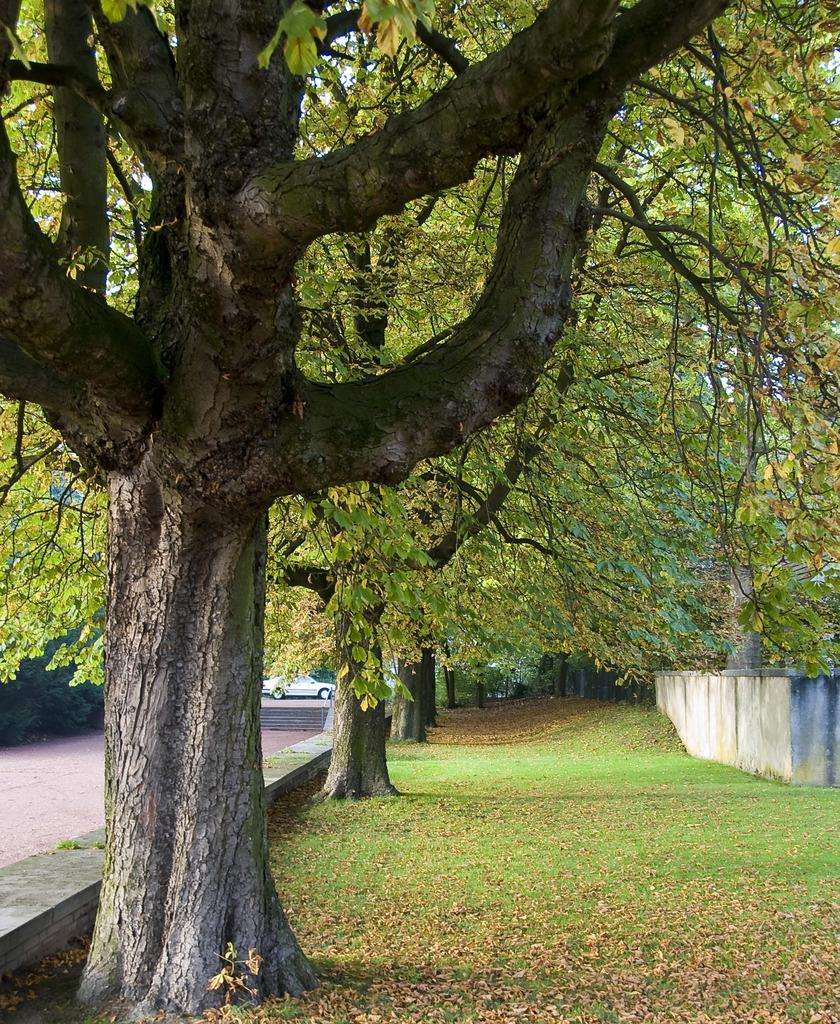What is located in the center of the image? There are trees in the center of the image. What type of vegetation can be seen on the ground? Dry leaves and grass are visible in the image. What can be seen in the image that might be used for transportation? There is a car in the image. What type of surface is visible in the image that might be used for walking or driving? There is a path in the image. What type of structure is visible in the image? There is a wall in the image. What type of ear is visible in the image? There is no ear present in the image. What type of machine is being used to cut the grass in the image? There is no machine visible in the image; the grass is not being cut. 